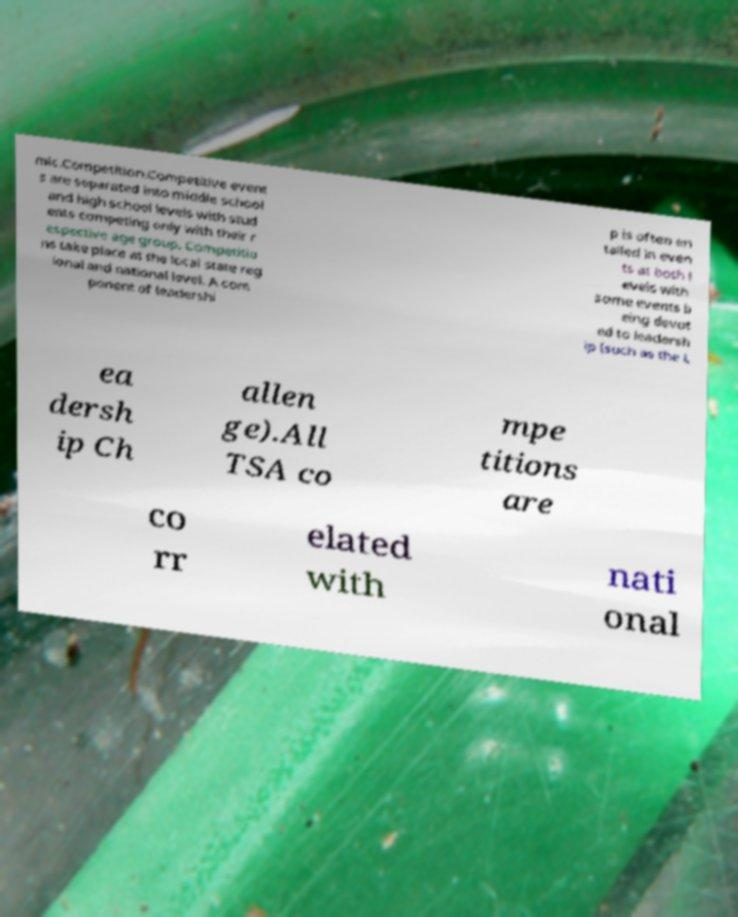Can you accurately transcribe the text from the provided image for me? mic.Competition.Competitive event s are separated into middle school and high school levels with stud ents competing only with their r espective age group. Competitio ns take place at the local state reg ional and national level. A com ponent of leadershi p is often en tailed in even ts at both l evels with some events b eing devot ed to leadersh ip (such as the L ea dersh ip Ch allen ge).All TSA co mpe titions are co rr elated with nati onal 